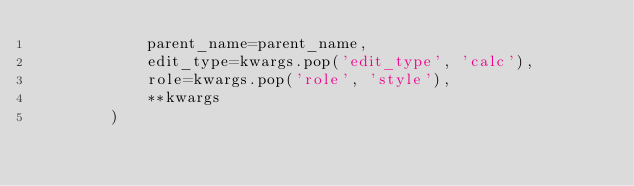Convert code to text. <code><loc_0><loc_0><loc_500><loc_500><_Python_>            parent_name=parent_name,
            edit_type=kwargs.pop('edit_type', 'calc'),
            role=kwargs.pop('role', 'style'),
            **kwargs
        )
</code> 